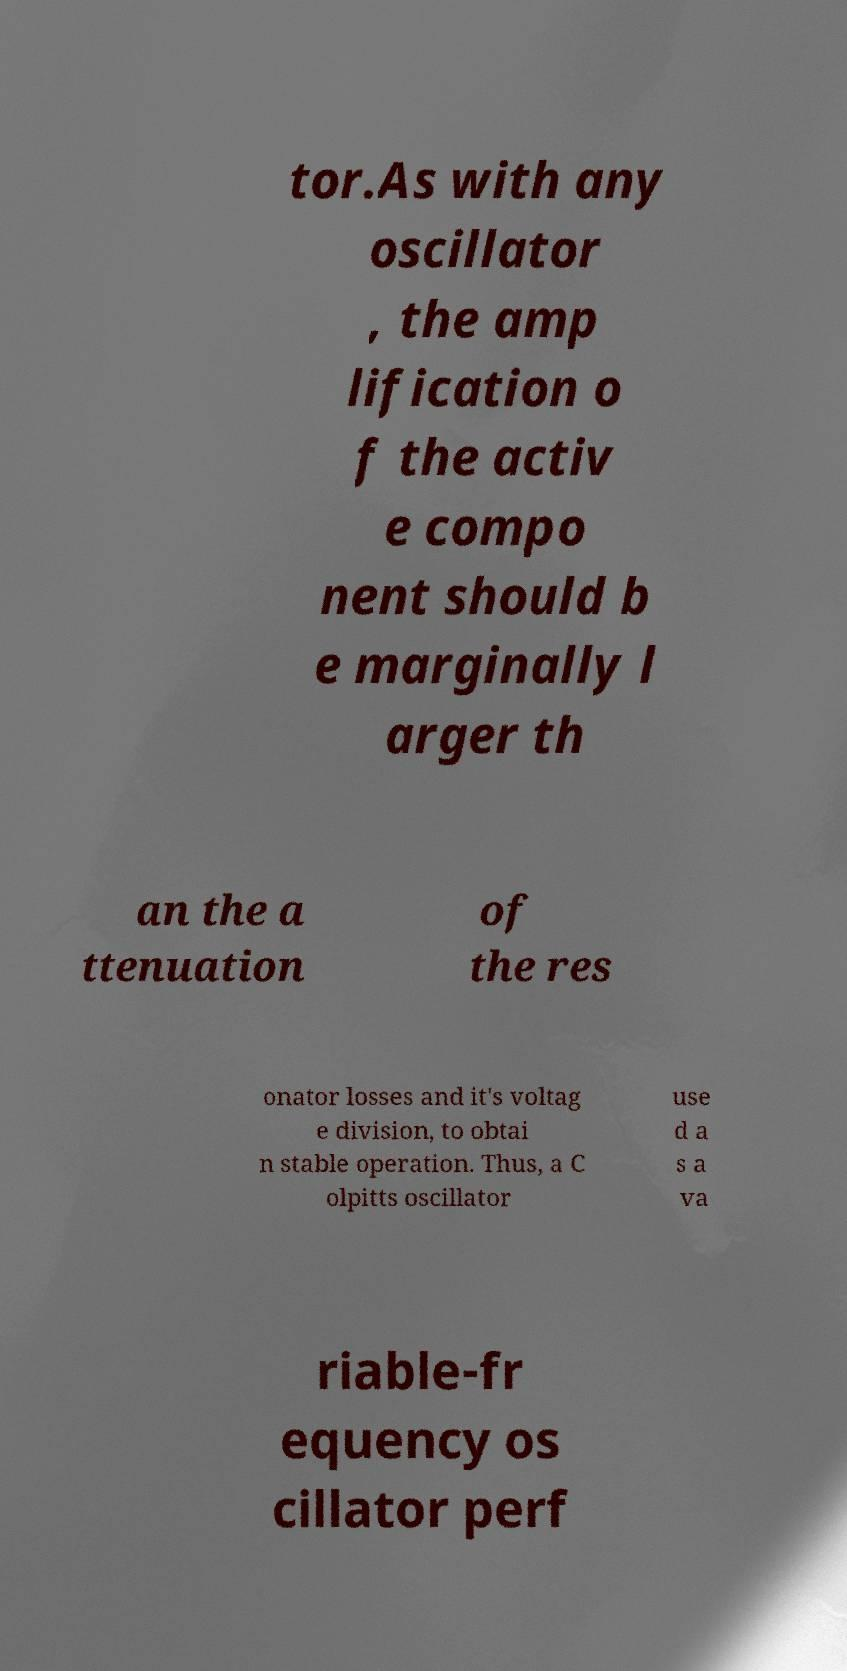Please identify and transcribe the text found in this image. tor.As with any oscillator , the amp lification o f the activ e compo nent should b e marginally l arger th an the a ttenuation of the res onator losses and it's voltag e division, to obtai n stable operation. Thus, a C olpitts oscillator use d a s a va riable-fr equency os cillator perf 